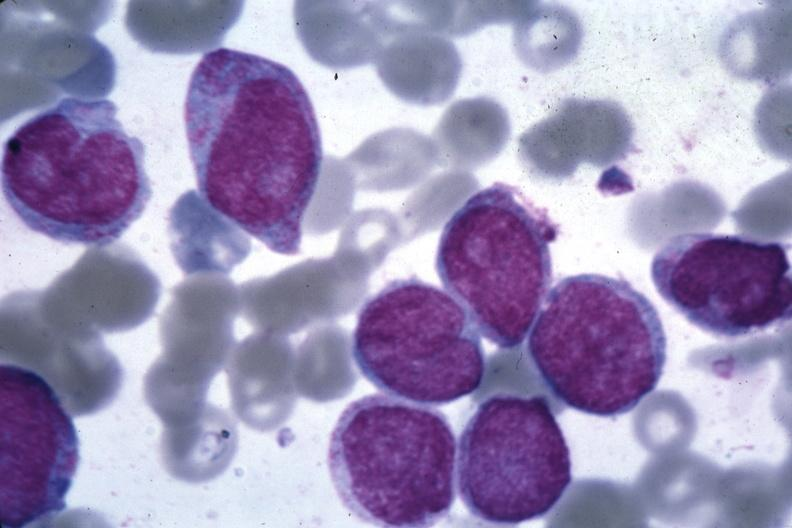what is present?
Answer the question using a single word or phrase. Bone marrow 